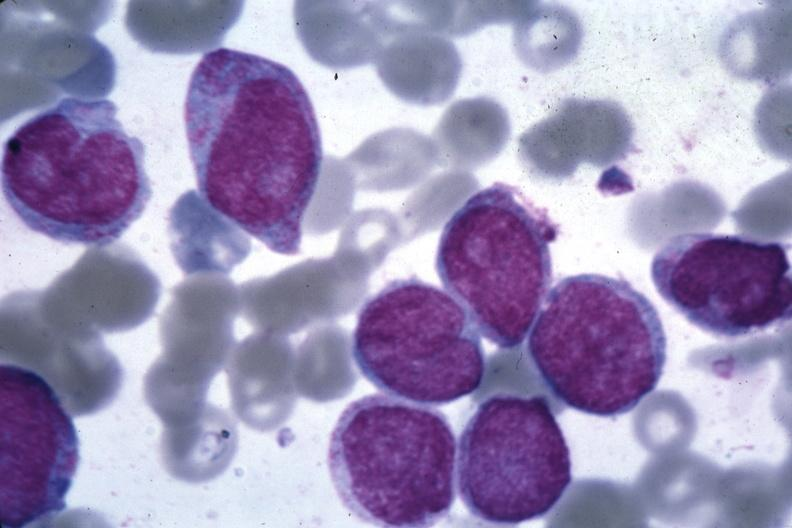what is present?
Answer the question using a single word or phrase. Bone marrow 